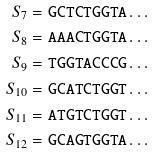<formula> <loc_0><loc_0><loc_500><loc_500>S _ { 7 } & = { \tt G C T C T G G T A } \dots \\ S _ { 8 } & = { \tt A A A C T G G T A } \dots \\ S _ { 9 } & = { \tt T G G T A C C C G } \dots \\ S _ { 1 0 } & = { \tt G C A T C T G G T } \dots \\ S _ { 1 1 } & = { \tt A T G T C T G G T } \dots \\ S _ { 1 2 } & = { \tt G C A G T G G T A } \dots</formula> 